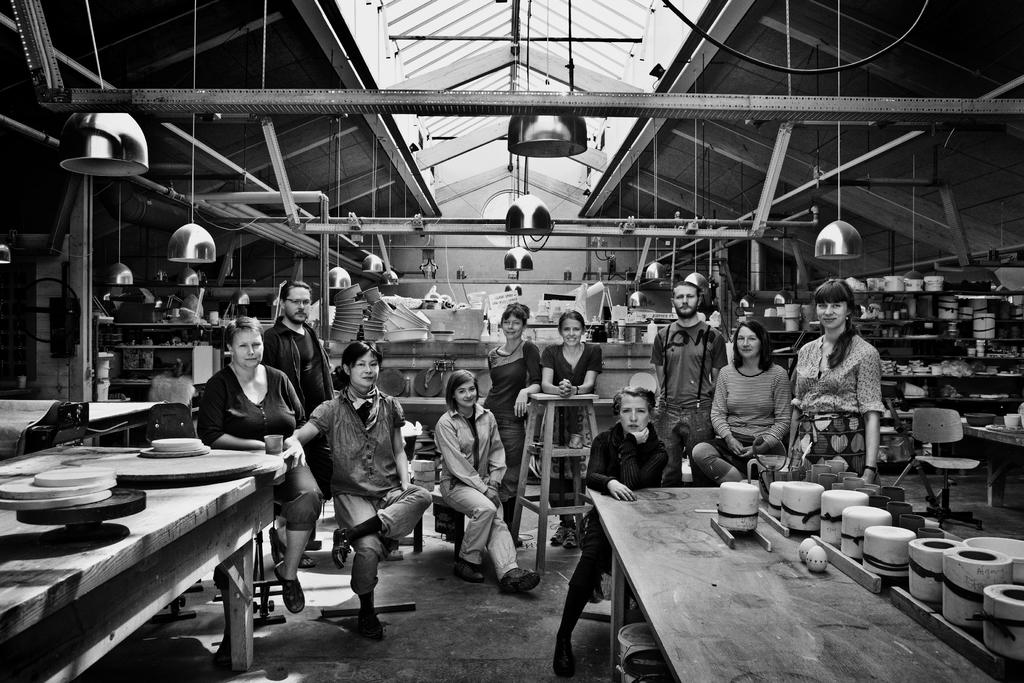How many people are present in the image? There are multiple people in the image. What are some of the people doing in the image? Some of the people are sitting, and some are standing. What can be seen in the background of the image? There are lights visible in the background of the image. What type of glass is being used by the people in the image? There is no glass present in the image; it only shows people sitting and standing. What kind of car can be seen in the background of the image? There is no car visible in the background of the image; only lights are mentioned. 